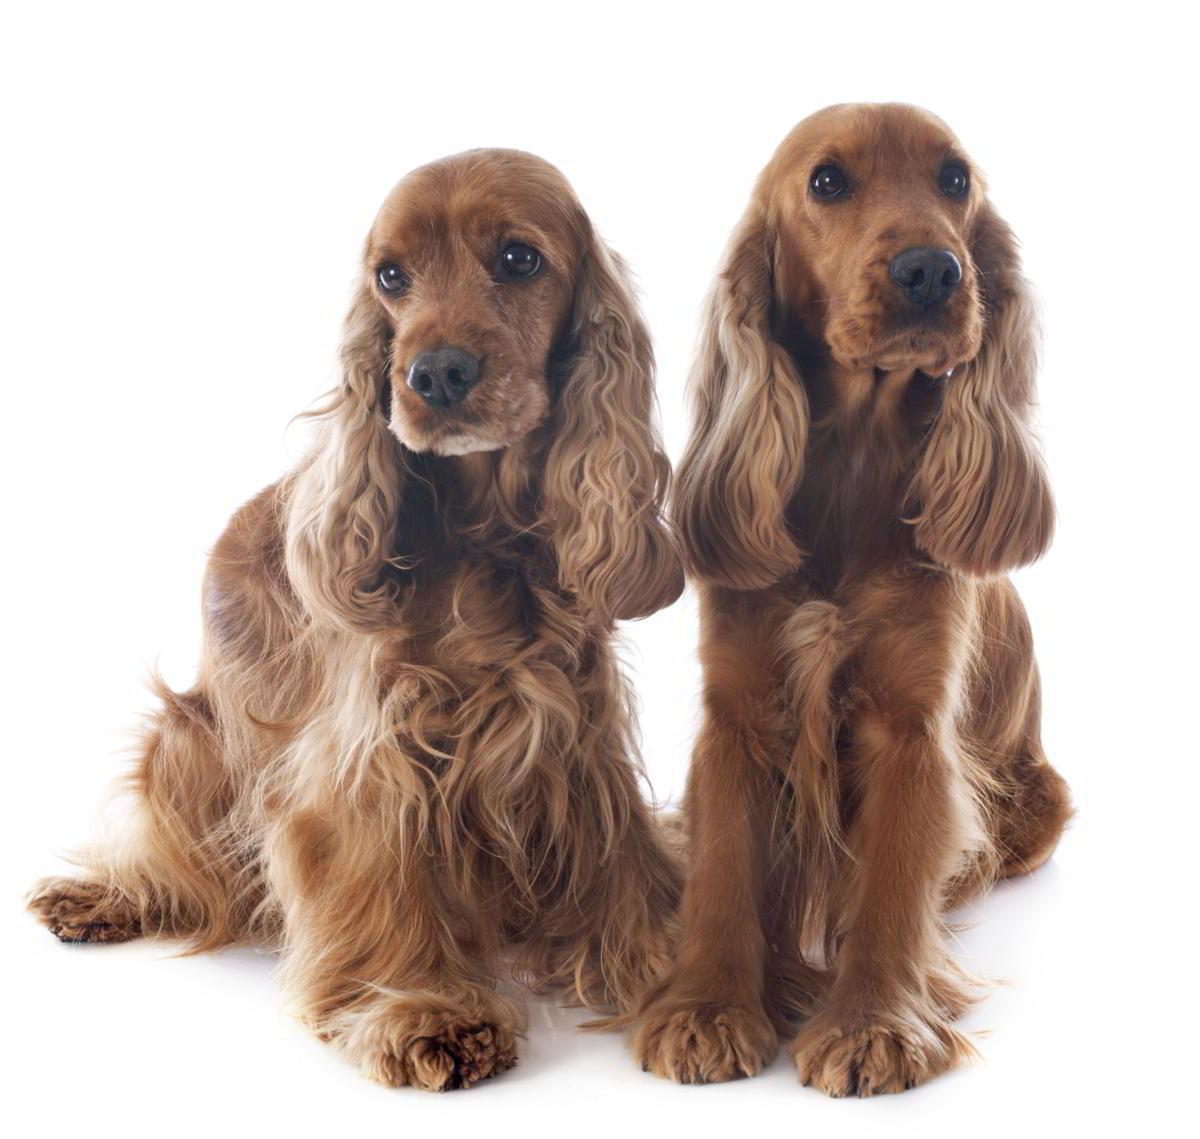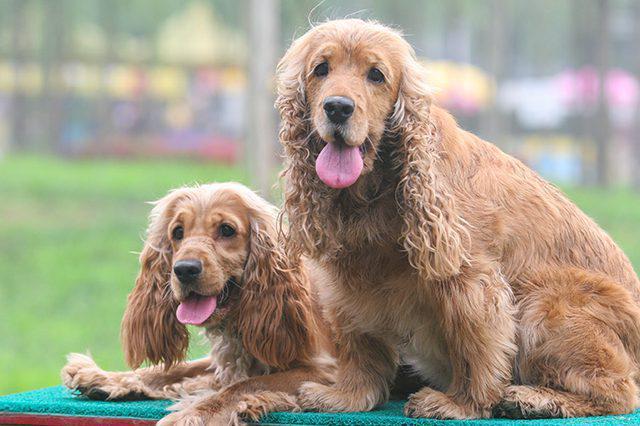The first image is the image on the left, the second image is the image on the right. Assess this claim about the two images: "There are two dogs facing forward with their tongues out in the image on the right.". Correct or not? Answer yes or no. Yes. The first image is the image on the left, the second image is the image on the right. Evaluate the accuracy of this statement regarding the images: "There is at least one dog with some black fur.". Is it true? Answer yes or no. No. 